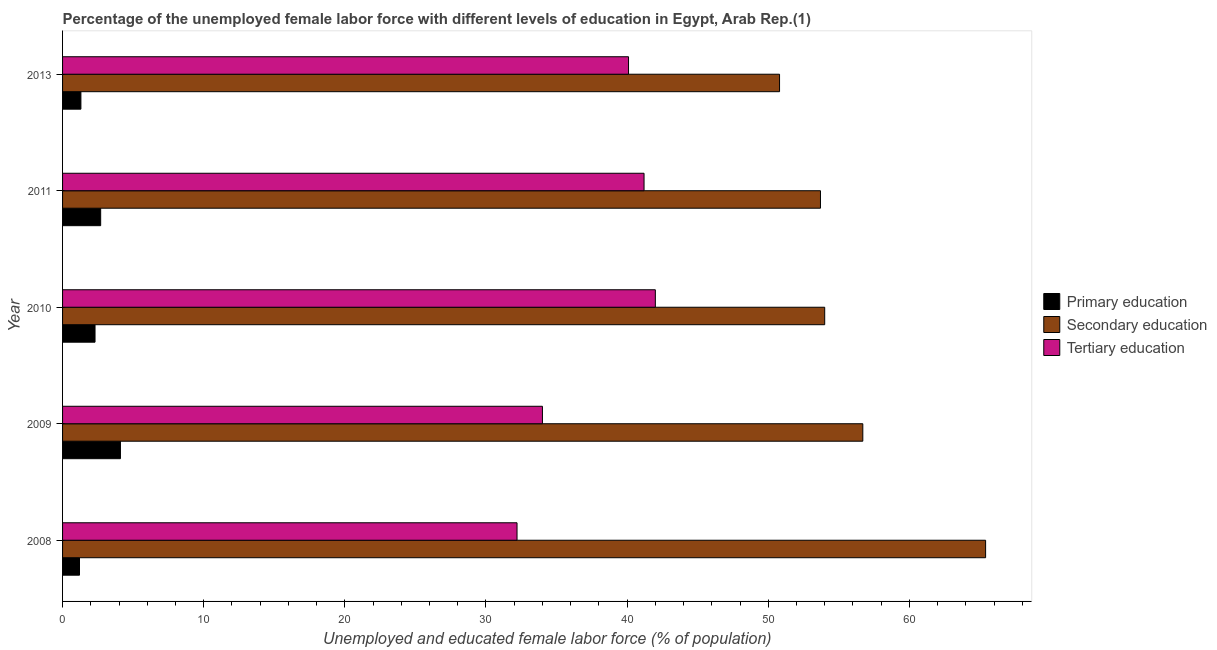Are the number of bars on each tick of the Y-axis equal?
Provide a succinct answer. Yes. How many bars are there on the 2nd tick from the top?
Give a very brief answer. 3. How many bars are there on the 1st tick from the bottom?
Give a very brief answer. 3. In how many cases, is the number of bars for a given year not equal to the number of legend labels?
Ensure brevity in your answer.  0. What is the percentage of female labor force who received secondary education in 2009?
Provide a succinct answer. 56.7. Across all years, what is the maximum percentage of female labor force who received secondary education?
Offer a very short reply. 65.4. Across all years, what is the minimum percentage of female labor force who received tertiary education?
Give a very brief answer. 32.2. In which year was the percentage of female labor force who received secondary education maximum?
Your answer should be very brief. 2008. In which year was the percentage of female labor force who received secondary education minimum?
Your response must be concise. 2013. What is the total percentage of female labor force who received primary education in the graph?
Your answer should be compact. 11.6. What is the difference between the percentage of female labor force who received tertiary education in 2009 and that in 2010?
Offer a very short reply. -8. What is the difference between the percentage of female labor force who received tertiary education in 2011 and the percentage of female labor force who received secondary education in 2013?
Provide a short and direct response. -9.6. What is the average percentage of female labor force who received tertiary education per year?
Ensure brevity in your answer.  37.9. In the year 2008, what is the difference between the percentage of female labor force who received primary education and percentage of female labor force who received tertiary education?
Keep it short and to the point. -31. What is the ratio of the percentage of female labor force who received primary education in 2010 to that in 2011?
Make the answer very short. 0.85. Is the difference between the percentage of female labor force who received secondary education in 2008 and 2011 greater than the difference between the percentage of female labor force who received primary education in 2008 and 2011?
Provide a succinct answer. Yes. What is the difference between the highest and the lowest percentage of female labor force who received tertiary education?
Your response must be concise. 9.8. In how many years, is the percentage of female labor force who received secondary education greater than the average percentage of female labor force who received secondary education taken over all years?
Provide a short and direct response. 2. Is the sum of the percentage of female labor force who received tertiary education in 2010 and 2013 greater than the maximum percentage of female labor force who received primary education across all years?
Make the answer very short. Yes. What does the 1st bar from the top in 2011 represents?
Ensure brevity in your answer.  Tertiary education. What does the 1st bar from the bottom in 2010 represents?
Your answer should be compact. Primary education. Is it the case that in every year, the sum of the percentage of female labor force who received primary education and percentage of female labor force who received secondary education is greater than the percentage of female labor force who received tertiary education?
Ensure brevity in your answer.  Yes. Are all the bars in the graph horizontal?
Keep it short and to the point. Yes. Are the values on the major ticks of X-axis written in scientific E-notation?
Your answer should be compact. No. Does the graph contain any zero values?
Offer a terse response. No. Where does the legend appear in the graph?
Make the answer very short. Center right. How many legend labels are there?
Offer a terse response. 3. What is the title of the graph?
Your answer should be very brief. Percentage of the unemployed female labor force with different levels of education in Egypt, Arab Rep.(1). Does "Social Insurance" appear as one of the legend labels in the graph?
Provide a short and direct response. No. What is the label or title of the X-axis?
Offer a terse response. Unemployed and educated female labor force (% of population). What is the Unemployed and educated female labor force (% of population) of Primary education in 2008?
Your answer should be compact. 1.2. What is the Unemployed and educated female labor force (% of population) in Secondary education in 2008?
Your response must be concise. 65.4. What is the Unemployed and educated female labor force (% of population) in Tertiary education in 2008?
Your answer should be compact. 32.2. What is the Unemployed and educated female labor force (% of population) of Primary education in 2009?
Make the answer very short. 4.1. What is the Unemployed and educated female labor force (% of population) of Secondary education in 2009?
Your response must be concise. 56.7. What is the Unemployed and educated female labor force (% of population) in Primary education in 2010?
Offer a terse response. 2.3. What is the Unemployed and educated female labor force (% of population) of Secondary education in 2010?
Offer a terse response. 54. What is the Unemployed and educated female labor force (% of population) in Tertiary education in 2010?
Give a very brief answer. 42. What is the Unemployed and educated female labor force (% of population) of Primary education in 2011?
Your answer should be very brief. 2.7. What is the Unemployed and educated female labor force (% of population) in Secondary education in 2011?
Keep it short and to the point. 53.7. What is the Unemployed and educated female labor force (% of population) in Tertiary education in 2011?
Your response must be concise. 41.2. What is the Unemployed and educated female labor force (% of population) of Primary education in 2013?
Keep it short and to the point. 1.3. What is the Unemployed and educated female labor force (% of population) of Secondary education in 2013?
Ensure brevity in your answer.  50.8. What is the Unemployed and educated female labor force (% of population) in Tertiary education in 2013?
Your answer should be compact. 40.1. Across all years, what is the maximum Unemployed and educated female labor force (% of population) in Primary education?
Keep it short and to the point. 4.1. Across all years, what is the maximum Unemployed and educated female labor force (% of population) of Secondary education?
Give a very brief answer. 65.4. Across all years, what is the maximum Unemployed and educated female labor force (% of population) of Tertiary education?
Offer a terse response. 42. Across all years, what is the minimum Unemployed and educated female labor force (% of population) in Primary education?
Keep it short and to the point. 1.2. Across all years, what is the minimum Unemployed and educated female labor force (% of population) in Secondary education?
Ensure brevity in your answer.  50.8. Across all years, what is the minimum Unemployed and educated female labor force (% of population) in Tertiary education?
Provide a short and direct response. 32.2. What is the total Unemployed and educated female labor force (% of population) in Secondary education in the graph?
Provide a short and direct response. 280.6. What is the total Unemployed and educated female labor force (% of population) in Tertiary education in the graph?
Offer a very short reply. 189.5. What is the difference between the Unemployed and educated female labor force (% of population) in Tertiary education in 2008 and that in 2010?
Your response must be concise. -9.8. What is the difference between the Unemployed and educated female labor force (% of population) of Secondary education in 2008 and that in 2011?
Offer a terse response. 11.7. What is the difference between the Unemployed and educated female labor force (% of population) of Tertiary education in 2008 and that in 2011?
Make the answer very short. -9. What is the difference between the Unemployed and educated female labor force (% of population) of Primary education in 2008 and that in 2013?
Your response must be concise. -0.1. What is the difference between the Unemployed and educated female labor force (% of population) in Secondary education in 2008 and that in 2013?
Offer a terse response. 14.6. What is the difference between the Unemployed and educated female labor force (% of population) of Tertiary education in 2008 and that in 2013?
Make the answer very short. -7.9. What is the difference between the Unemployed and educated female labor force (% of population) in Secondary education in 2009 and that in 2010?
Ensure brevity in your answer.  2.7. What is the difference between the Unemployed and educated female labor force (% of population) of Primary education in 2009 and that in 2011?
Offer a very short reply. 1.4. What is the difference between the Unemployed and educated female labor force (% of population) of Secondary education in 2009 and that in 2011?
Ensure brevity in your answer.  3. What is the difference between the Unemployed and educated female labor force (% of population) of Tertiary education in 2009 and that in 2011?
Keep it short and to the point. -7.2. What is the difference between the Unemployed and educated female labor force (% of population) of Primary education in 2009 and that in 2013?
Offer a terse response. 2.8. What is the difference between the Unemployed and educated female labor force (% of population) of Secondary education in 2010 and that in 2013?
Give a very brief answer. 3.2. What is the difference between the Unemployed and educated female labor force (% of population) of Tertiary education in 2010 and that in 2013?
Offer a very short reply. 1.9. What is the difference between the Unemployed and educated female labor force (% of population) of Primary education in 2011 and that in 2013?
Offer a terse response. 1.4. What is the difference between the Unemployed and educated female labor force (% of population) of Secondary education in 2011 and that in 2013?
Give a very brief answer. 2.9. What is the difference between the Unemployed and educated female labor force (% of population) of Primary education in 2008 and the Unemployed and educated female labor force (% of population) of Secondary education in 2009?
Provide a short and direct response. -55.5. What is the difference between the Unemployed and educated female labor force (% of population) of Primary education in 2008 and the Unemployed and educated female labor force (% of population) of Tertiary education in 2009?
Ensure brevity in your answer.  -32.8. What is the difference between the Unemployed and educated female labor force (% of population) in Secondary education in 2008 and the Unemployed and educated female labor force (% of population) in Tertiary education in 2009?
Your answer should be very brief. 31.4. What is the difference between the Unemployed and educated female labor force (% of population) of Primary education in 2008 and the Unemployed and educated female labor force (% of population) of Secondary education in 2010?
Your answer should be very brief. -52.8. What is the difference between the Unemployed and educated female labor force (% of population) of Primary education in 2008 and the Unemployed and educated female labor force (% of population) of Tertiary education in 2010?
Keep it short and to the point. -40.8. What is the difference between the Unemployed and educated female labor force (% of population) of Secondary education in 2008 and the Unemployed and educated female labor force (% of population) of Tertiary education in 2010?
Keep it short and to the point. 23.4. What is the difference between the Unemployed and educated female labor force (% of population) in Primary education in 2008 and the Unemployed and educated female labor force (% of population) in Secondary education in 2011?
Provide a succinct answer. -52.5. What is the difference between the Unemployed and educated female labor force (% of population) in Secondary education in 2008 and the Unemployed and educated female labor force (% of population) in Tertiary education in 2011?
Offer a terse response. 24.2. What is the difference between the Unemployed and educated female labor force (% of population) in Primary education in 2008 and the Unemployed and educated female labor force (% of population) in Secondary education in 2013?
Your answer should be very brief. -49.6. What is the difference between the Unemployed and educated female labor force (% of population) of Primary education in 2008 and the Unemployed and educated female labor force (% of population) of Tertiary education in 2013?
Keep it short and to the point. -38.9. What is the difference between the Unemployed and educated female labor force (% of population) of Secondary education in 2008 and the Unemployed and educated female labor force (% of population) of Tertiary education in 2013?
Offer a terse response. 25.3. What is the difference between the Unemployed and educated female labor force (% of population) in Primary education in 2009 and the Unemployed and educated female labor force (% of population) in Secondary education in 2010?
Your answer should be compact. -49.9. What is the difference between the Unemployed and educated female labor force (% of population) of Primary education in 2009 and the Unemployed and educated female labor force (% of population) of Tertiary education in 2010?
Your answer should be compact. -37.9. What is the difference between the Unemployed and educated female labor force (% of population) of Secondary education in 2009 and the Unemployed and educated female labor force (% of population) of Tertiary education in 2010?
Ensure brevity in your answer.  14.7. What is the difference between the Unemployed and educated female labor force (% of population) in Primary education in 2009 and the Unemployed and educated female labor force (% of population) in Secondary education in 2011?
Your response must be concise. -49.6. What is the difference between the Unemployed and educated female labor force (% of population) of Primary education in 2009 and the Unemployed and educated female labor force (% of population) of Tertiary education in 2011?
Your answer should be compact. -37.1. What is the difference between the Unemployed and educated female labor force (% of population) in Secondary education in 2009 and the Unemployed and educated female labor force (% of population) in Tertiary education in 2011?
Your answer should be compact. 15.5. What is the difference between the Unemployed and educated female labor force (% of population) in Primary education in 2009 and the Unemployed and educated female labor force (% of population) in Secondary education in 2013?
Offer a very short reply. -46.7. What is the difference between the Unemployed and educated female labor force (% of population) of Primary education in 2009 and the Unemployed and educated female labor force (% of population) of Tertiary education in 2013?
Make the answer very short. -36. What is the difference between the Unemployed and educated female labor force (% of population) of Secondary education in 2009 and the Unemployed and educated female labor force (% of population) of Tertiary education in 2013?
Keep it short and to the point. 16.6. What is the difference between the Unemployed and educated female labor force (% of population) of Primary education in 2010 and the Unemployed and educated female labor force (% of population) of Secondary education in 2011?
Make the answer very short. -51.4. What is the difference between the Unemployed and educated female labor force (% of population) of Primary education in 2010 and the Unemployed and educated female labor force (% of population) of Tertiary education in 2011?
Provide a succinct answer. -38.9. What is the difference between the Unemployed and educated female labor force (% of population) in Primary education in 2010 and the Unemployed and educated female labor force (% of population) in Secondary education in 2013?
Your answer should be very brief. -48.5. What is the difference between the Unemployed and educated female labor force (% of population) in Primary education in 2010 and the Unemployed and educated female labor force (% of population) in Tertiary education in 2013?
Provide a succinct answer. -37.8. What is the difference between the Unemployed and educated female labor force (% of population) of Secondary education in 2010 and the Unemployed and educated female labor force (% of population) of Tertiary education in 2013?
Offer a very short reply. 13.9. What is the difference between the Unemployed and educated female labor force (% of population) of Primary education in 2011 and the Unemployed and educated female labor force (% of population) of Secondary education in 2013?
Offer a very short reply. -48.1. What is the difference between the Unemployed and educated female labor force (% of population) of Primary education in 2011 and the Unemployed and educated female labor force (% of population) of Tertiary education in 2013?
Offer a very short reply. -37.4. What is the difference between the Unemployed and educated female labor force (% of population) in Secondary education in 2011 and the Unemployed and educated female labor force (% of population) in Tertiary education in 2013?
Provide a succinct answer. 13.6. What is the average Unemployed and educated female labor force (% of population) in Primary education per year?
Your response must be concise. 2.32. What is the average Unemployed and educated female labor force (% of population) in Secondary education per year?
Provide a succinct answer. 56.12. What is the average Unemployed and educated female labor force (% of population) in Tertiary education per year?
Give a very brief answer. 37.9. In the year 2008, what is the difference between the Unemployed and educated female labor force (% of population) of Primary education and Unemployed and educated female labor force (% of population) of Secondary education?
Provide a succinct answer. -64.2. In the year 2008, what is the difference between the Unemployed and educated female labor force (% of population) of Primary education and Unemployed and educated female labor force (% of population) of Tertiary education?
Keep it short and to the point. -31. In the year 2008, what is the difference between the Unemployed and educated female labor force (% of population) in Secondary education and Unemployed and educated female labor force (% of population) in Tertiary education?
Provide a succinct answer. 33.2. In the year 2009, what is the difference between the Unemployed and educated female labor force (% of population) in Primary education and Unemployed and educated female labor force (% of population) in Secondary education?
Give a very brief answer. -52.6. In the year 2009, what is the difference between the Unemployed and educated female labor force (% of population) in Primary education and Unemployed and educated female labor force (% of population) in Tertiary education?
Provide a short and direct response. -29.9. In the year 2009, what is the difference between the Unemployed and educated female labor force (% of population) in Secondary education and Unemployed and educated female labor force (% of population) in Tertiary education?
Your answer should be very brief. 22.7. In the year 2010, what is the difference between the Unemployed and educated female labor force (% of population) of Primary education and Unemployed and educated female labor force (% of population) of Secondary education?
Keep it short and to the point. -51.7. In the year 2010, what is the difference between the Unemployed and educated female labor force (% of population) in Primary education and Unemployed and educated female labor force (% of population) in Tertiary education?
Keep it short and to the point. -39.7. In the year 2011, what is the difference between the Unemployed and educated female labor force (% of population) in Primary education and Unemployed and educated female labor force (% of population) in Secondary education?
Provide a short and direct response. -51. In the year 2011, what is the difference between the Unemployed and educated female labor force (% of population) of Primary education and Unemployed and educated female labor force (% of population) of Tertiary education?
Provide a short and direct response. -38.5. In the year 2013, what is the difference between the Unemployed and educated female labor force (% of population) in Primary education and Unemployed and educated female labor force (% of population) in Secondary education?
Offer a very short reply. -49.5. In the year 2013, what is the difference between the Unemployed and educated female labor force (% of population) of Primary education and Unemployed and educated female labor force (% of population) of Tertiary education?
Ensure brevity in your answer.  -38.8. What is the ratio of the Unemployed and educated female labor force (% of population) in Primary education in 2008 to that in 2009?
Your answer should be compact. 0.29. What is the ratio of the Unemployed and educated female labor force (% of population) of Secondary education in 2008 to that in 2009?
Keep it short and to the point. 1.15. What is the ratio of the Unemployed and educated female labor force (% of population) in Tertiary education in 2008 to that in 2009?
Make the answer very short. 0.95. What is the ratio of the Unemployed and educated female labor force (% of population) in Primary education in 2008 to that in 2010?
Keep it short and to the point. 0.52. What is the ratio of the Unemployed and educated female labor force (% of population) of Secondary education in 2008 to that in 2010?
Your answer should be very brief. 1.21. What is the ratio of the Unemployed and educated female labor force (% of population) of Tertiary education in 2008 to that in 2010?
Make the answer very short. 0.77. What is the ratio of the Unemployed and educated female labor force (% of population) in Primary education in 2008 to that in 2011?
Your answer should be compact. 0.44. What is the ratio of the Unemployed and educated female labor force (% of population) in Secondary education in 2008 to that in 2011?
Keep it short and to the point. 1.22. What is the ratio of the Unemployed and educated female labor force (% of population) of Tertiary education in 2008 to that in 2011?
Provide a succinct answer. 0.78. What is the ratio of the Unemployed and educated female labor force (% of population) in Primary education in 2008 to that in 2013?
Give a very brief answer. 0.92. What is the ratio of the Unemployed and educated female labor force (% of population) in Secondary education in 2008 to that in 2013?
Give a very brief answer. 1.29. What is the ratio of the Unemployed and educated female labor force (% of population) in Tertiary education in 2008 to that in 2013?
Offer a very short reply. 0.8. What is the ratio of the Unemployed and educated female labor force (% of population) in Primary education in 2009 to that in 2010?
Your answer should be very brief. 1.78. What is the ratio of the Unemployed and educated female labor force (% of population) in Tertiary education in 2009 to that in 2010?
Provide a short and direct response. 0.81. What is the ratio of the Unemployed and educated female labor force (% of population) of Primary education in 2009 to that in 2011?
Offer a very short reply. 1.52. What is the ratio of the Unemployed and educated female labor force (% of population) of Secondary education in 2009 to that in 2011?
Give a very brief answer. 1.06. What is the ratio of the Unemployed and educated female labor force (% of population) of Tertiary education in 2009 to that in 2011?
Keep it short and to the point. 0.83. What is the ratio of the Unemployed and educated female labor force (% of population) of Primary education in 2009 to that in 2013?
Provide a succinct answer. 3.15. What is the ratio of the Unemployed and educated female labor force (% of population) in Secondary education in 2009 to that in 2013?
Provide a short and direct response. 1.12. What is the ratio of the Unemployed and educated female labor force (% of population) of Tertiary education in 2009 to that in 2013?
Your answer should be very brief. 0.85. What is the ratio of the Unemployed and educated female labor force (% of population) of Primary education in 2010 to that in 2011?
Provide a succinct answer. 0.85. What is the ratio of the Unemployed and educated female labor force (% of population) in Secondary education in 2010 to that in 2011?
Offer a very short reply. 1.01. What is the ratio of the Unemployed and educated female labor force (% of population) in Tertiary education in 2010 to that in 2011?
Offer a terse response. 1.02. What is the ratio of the Unemployed and educated female labor force (% of population) of Primary education in 2010 to that in 2013?
Make the answer very short. 1.77. What is the ratio of the Unemployed and educated female labor force (% of population) of Secondary education in 2010 to that in 2013?
Provide a succinct answer. 1.06. What is the ratio of the Unemployed and educated female labor force (% of population) in Tertiary education in 2010 to that in 2013?
Give a very brief answer. 1.05. What is the ratio of the Unemployed and educated female labor force (% of population) in Primary education in 2011 to that in 2013?
Your response must be concise. 2.08. What is the ratio of the Unemployed and educated female labor force (% of population) of Secondary education in 2011 to that in 2013?
Offer a very short reply. 1.06. What is the ratio of the Unemployed and educated female labor force (% of population) of Tertiary education in 2011 to that in 2013?
Make the answer very short. 1.03. What is the difference between the highest and the second highest Unemployed and educated female labor force (% of population) of Primary education?
Give a very brief answer. 1.4. What is the difference between the highest and the lowest Unemployed and educated female labor force (% of population) in Secondary education?
Your response must be concise. 14.6. 